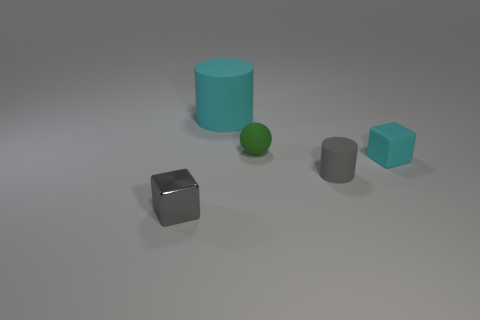Subtract all gray cylinders. How many cylinders are left? 1 Subtract all red cylinders. Subtract all red cubes. How many cylinders are left? 2 Subtract all yellow spheres. How many cyan cylinders are left? 1 Subtract all matte things. Subtract all tiny cyan things. How many objects are left? 0 Add 3 small matte balls. How many small matte balls are left? 4 Add 3 tiny green matte balls. How many tiny green matte balls exist? 4 Add 3 cyan cubes. How many objects exist? 8 Subtract 0 brown blocks. How many objects are left? 5 Subtract all blocks. How many objects are left? 3 Subtract 1 cylinders. How many cylinders are left? 1 